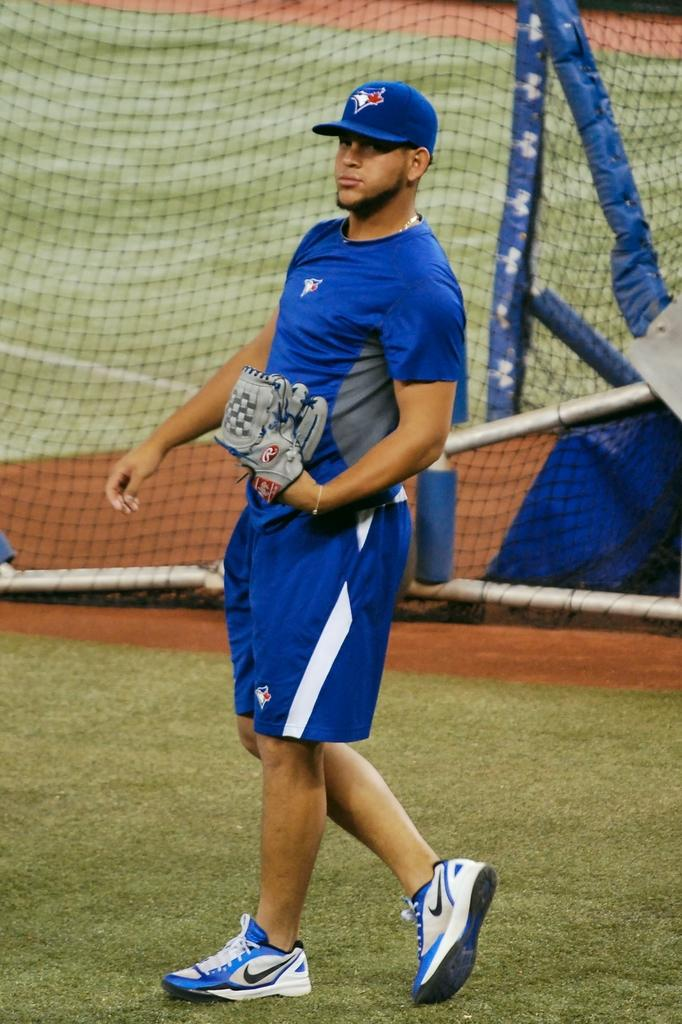What is the person in the image doing? There is a person walking in the image. What type of surface is the person walking on? The ground is covered with grass. What accessory is the person holding? The person is holding gloves. What type of headwear is the person wearing? The person is wearing a cap. What object is present in the image that might be used for catching or blocking? There is a net present in the image. What type of lock can be seen securing the person's pain in the image? There is no lock or pain present in the image; it features a person walking with gloves and a cap, and a net nearby. 